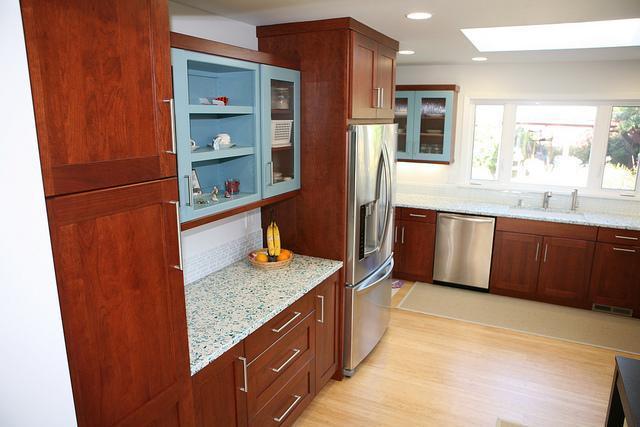How many people are holding a pink purse?
Give a very brief answer. 0. 